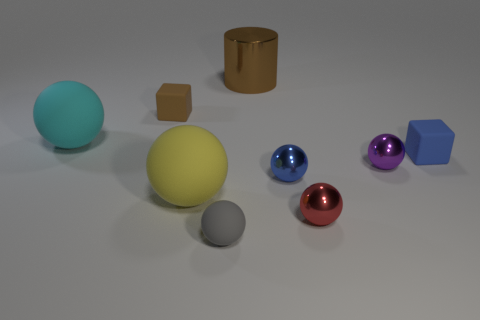Subtract 2 balls. How many balls are left? 4 Subtract all gray spheres. How many spheres are left? 5 Subtract all purple spheres. How many spheres are left? 5 Subtract all cyan balls. Subtract all cyan cubes. How many balls are left? 5 Subtract all cylinders. How many objects are left? 8 Add 4 big blue matte cylinders. How many big blue matte cylinders exist? 4 Subtract 1 red balls. How many objects are left? 8 Subtract all big yellow matte things. Subtract all large brown rubber cubes. How many objects are left? 8 Add 2 big brown cylinders. How many big brown cylinders are left? 3 